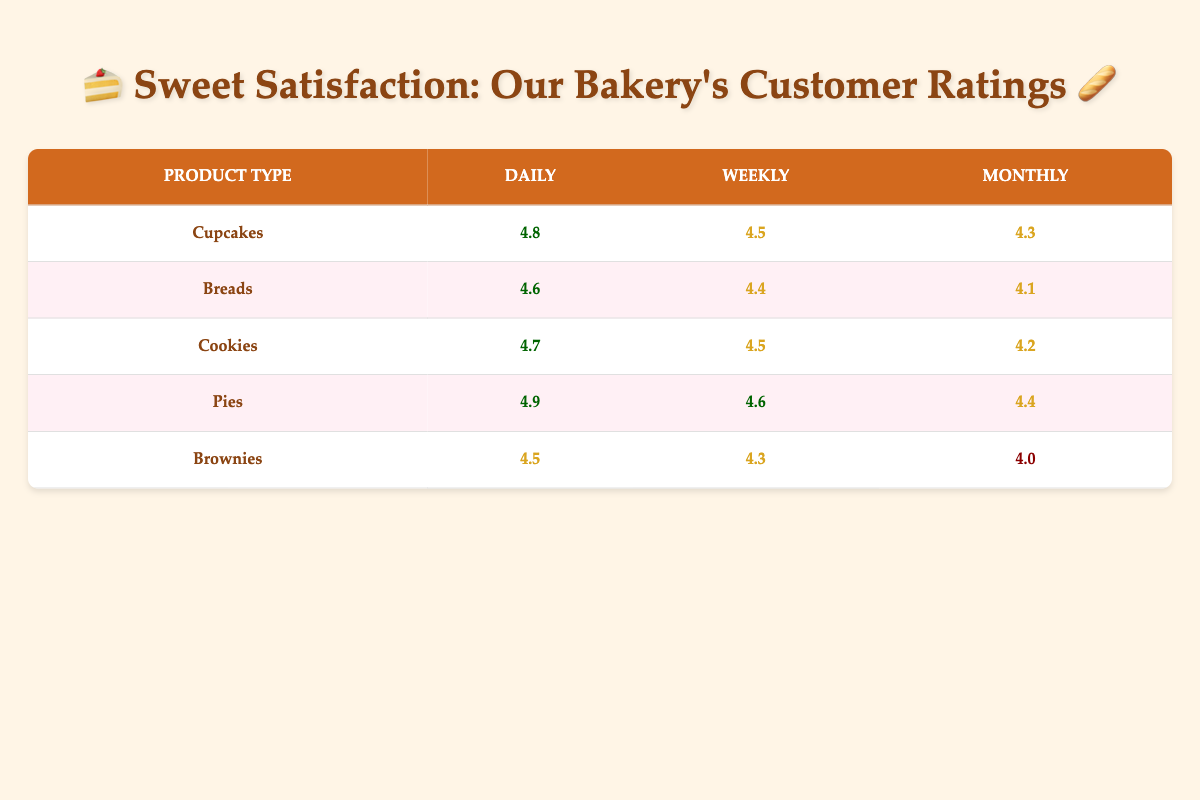What is the customer satisfaction rating for cookies purchased daily? The table shows that the customer satisfaction rating for cookies at a daily purchase frequency is 4.7.
Answer: 4.7 Which product type has the highest customer satisfaction rating for weekly purchases? Looking at the weekly ratings, Pies have the highest rating of 4.6, compared to Cupcakes (4.5), Breads (4.4), Cookies (4.5), and Brownies (4.3).
Answer: Pies Is the customer satisfaction rating for Breads purchased monthly lower than that for Cupcakes purchased monthly? The rating for Breads purchased monthly is 4.1, while for Cupcakes it is 4.3. Since 4.1 is less than 4.3, the statement is true.
Answer: Yes What is the average customer satisfaction rating for Daily purchases across all product types? The ratings for daily purchases are 4.8 (Cupcakes), 4.6 (Breads), 4.7 (Cookies), 4.9 (Pies), and 4.5 (Brownies). Adding these gives 4.8 + 4.6 + 4.7 + 4.9 + 4.5 = 24.5. There are 5 products, so the average is 24.5 / 5 = 4.9.
Answer: 4.9 How does the customer satisfaction rating for Brownies compare between Monthly and Daily purchases? For Brownies, the satisfaction rating is 4.0 for monthly purchases and 4.5 for daily purchases. Since 4.0 is less than 4.5, the satisfaction for daily is higher.
Answer: Daily is higher Which product type shows the most significant drop in satisfaction rating from Daily to Monthly purchase frequency? The satisfaction ratings are 4.9 to 4.4 for Pies, 4.6 to 4.1 for Breads, 4.7 to 4.2 for Cookies, 4.5 to 4.0 for Brownies, and 4.8 to 4.3 for Cupcakes. The most significant drop is for Brownies, which decreases by 0.5.
Answer: Brownies Is there any product type that has a customer satisfaction rating of 4.0 or lower? From the table data, the only product type with a rating of 4.0 is Brownies purchased monthly (4.0).
Answer: Yes What are the satisfaction ratings for Cupcakes across all purchase frequencies? The ratings for Cupcakes are 4.8 (Daily), 4.5 (Weekly), and 4.3 (Monthly).
Answer: 4.8, 4.5, 4.3 